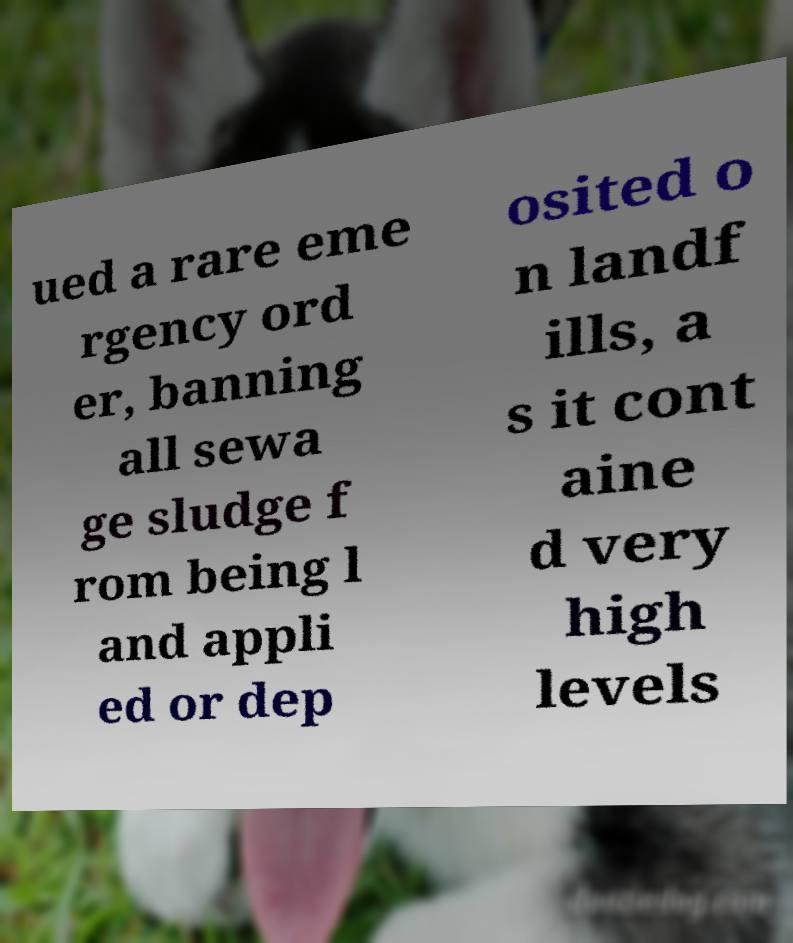Could you extract and type out the text from this image? ued a rare eme rgency ord er, banning all sewa ge sludge f rom being l and appli ed or dep osited o n landf ills, a s it cont aine d very high levels 